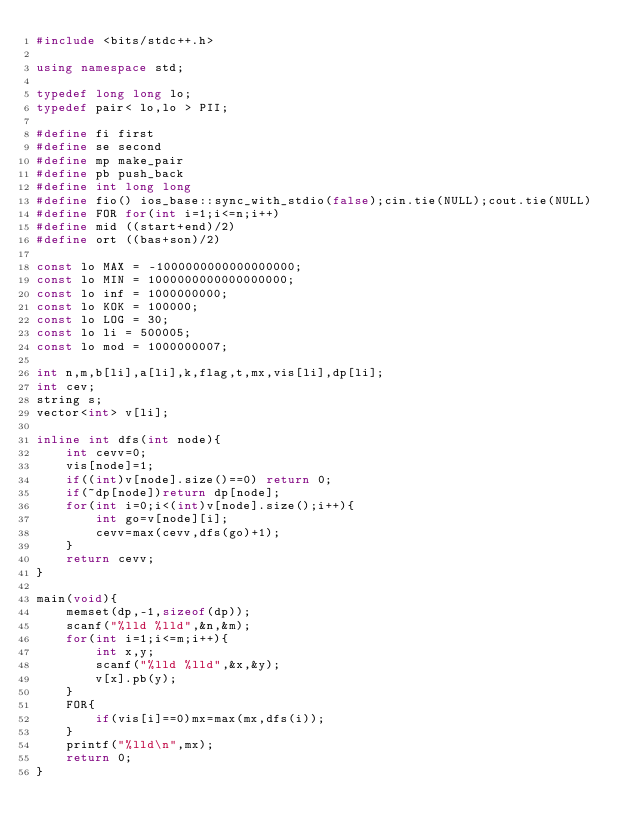Convert code to text. <code><loc_0><loc_0><loc_500><loc_500><_C++_>#include <bits/stdc++.h>

using namespace std;

typedef long long lo;
typedef pair< lo,lo > PII;

#define fi first
#define se second
#define mp make_pair
#define pb push_back
#define int long long
#define fio() ios_base::sync_with_stdio(false);cin.tie(NULL);cout.tie(NULL)
#define FOR for(int i=1;i<=n;i++)
#define mid ((start+end)/2)
#define ort ((bas+son)/2)

const lo MAX = -1000000000000000000;
const lo MIN = 1000000000000000000;
const lo inf = 1000000000;
const lo KOK = 100000;
const lo LOG = 30;
const lo li = 500005;
const lo mod = 1000000007;

int n,m,b[li],a[li],k,flag,t,mx,vis[li],dp[li];
int cev;
string s;
vector<int> v[li];

inline int dfs(int node){
	int cevv=0;
	vis[node]=1;
	if((int)v[node].size()==0) return 0;
	if(~dp[node])return dp[node];
	for(int i=0;i<(int)v[node].size();i++){
		int go=v[node][i];
		cevv=max(cevv,dfs(go)+1);
	}
	return cevv;
}

main(void){
	memset(dp,-1,sizeof(dp));
	scanf("%lld %lld",&n,&m);
	for(int i=1;i<=m;i++){
		int x,y;
		scanf("%lld %lld",&x,&y);
		v[x].pb(y);
	}
	FOR{
		if(vis[i]==0)mx=max(mx,dfs(i));
	}
	printf("%lld\n",mx);
	return 0;
}
</code> 